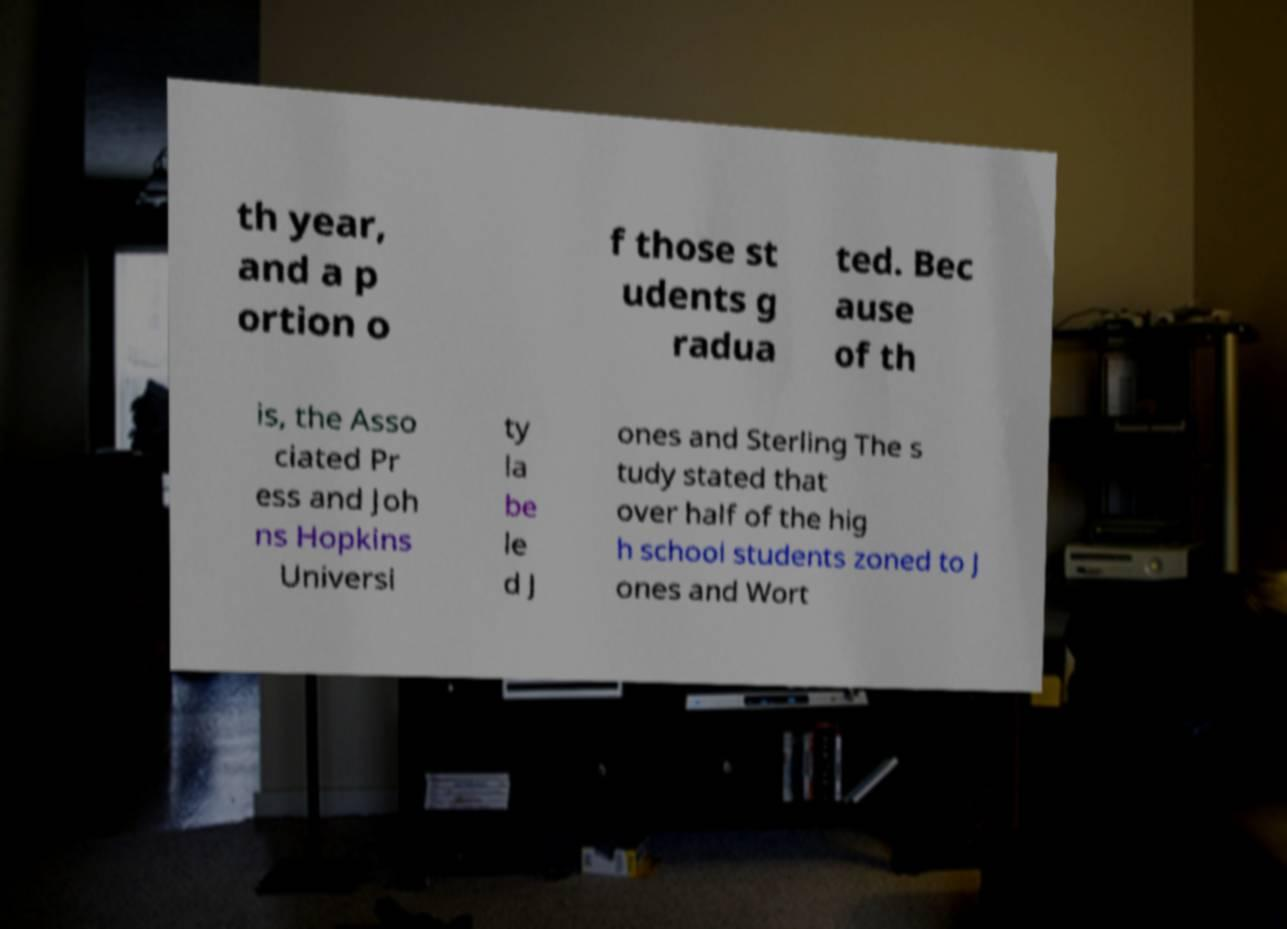Please read and relay the text visible in this image. What does it say? th year, and a p ortion o f those st udents g radua ted. Bec ause of th is, the Asso ciated Pr ess and Joh ns Hopkins Universi ty la be le d J ones and Sterling The s tudy stated that over half of the hig h school students zoned to J ones and Wort 